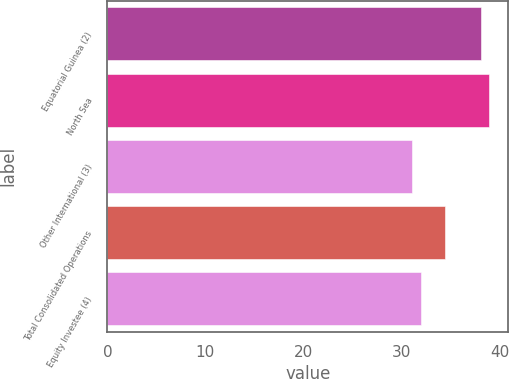<chart> <loc_0><loc_0><loc_500><loc_500><bar_chart><fcel>Equatorial Guinea (2)<fcel>North Sea<fcel>Other International (3)<fcel>Total Consolidated Operations<fcel>Equity Investee (4)<nl><fcel>38.16<fcel>38.94<fcel>31.06<fcel>34.48<fcel>32.01<nl></chart> 